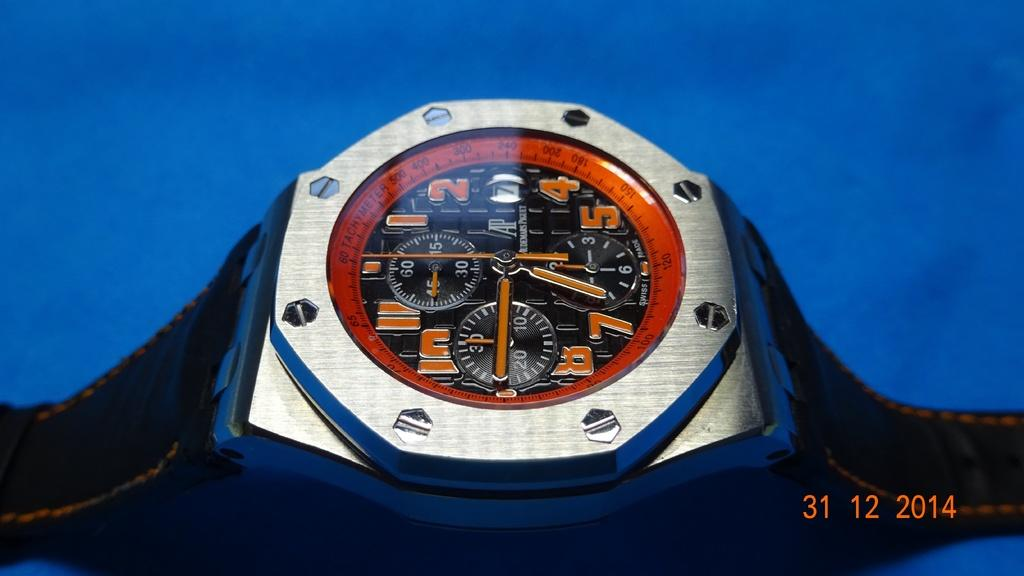<image>
Provide a brief description of the given image. A black and white watch with its hands signaling 6:45. 